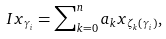<formula> <loc_0><loc_0><loc_500><loc_500>I x _ { \gamma _ { i } } = \sum \nolimits _ { k = 0 } ^ { n } a _ { k } x _ { \zeta _ { k } \left ( \gamma _ { i } \right ) } ,</formula> 